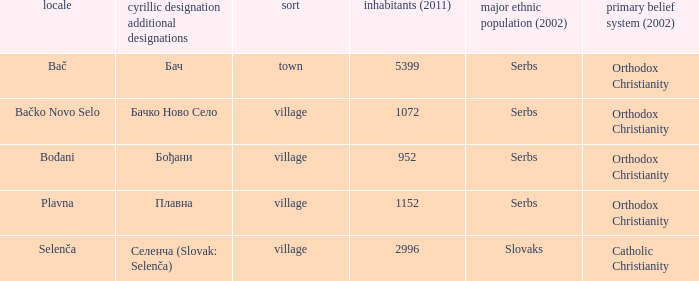How to you write  плавна with the latin alphabet? Plavna. Can you parse all the data within this table? {'header': ['locale', 'cyrillic designation additional designations', 'sort', 'inhabitants (2011)', 'major ethnic population (2002)', 'primary belief system (2002)'], 'rows': [['Bač', 'Бач', 'town', '5399', 'Serbs', 'Orthodox Christianity'], ['Bačko Novo Selo', 'Бачко Ново Село', 'village', '1072', 'Serbs', 'Orthodox Christianity'], ['Bođani', 'Бођани', 'village', '952', 'Serbs', 'Orthodox Christianity'], ['Plavna', 'Плавна', 'village', '1152', 'Serbs', 'Orthodox Christianity'], ['Selenča', 'Селенча (Slovak: Selenča)', 'village', '2996', 'Slovaks', 'Catholic Christianity']]} 